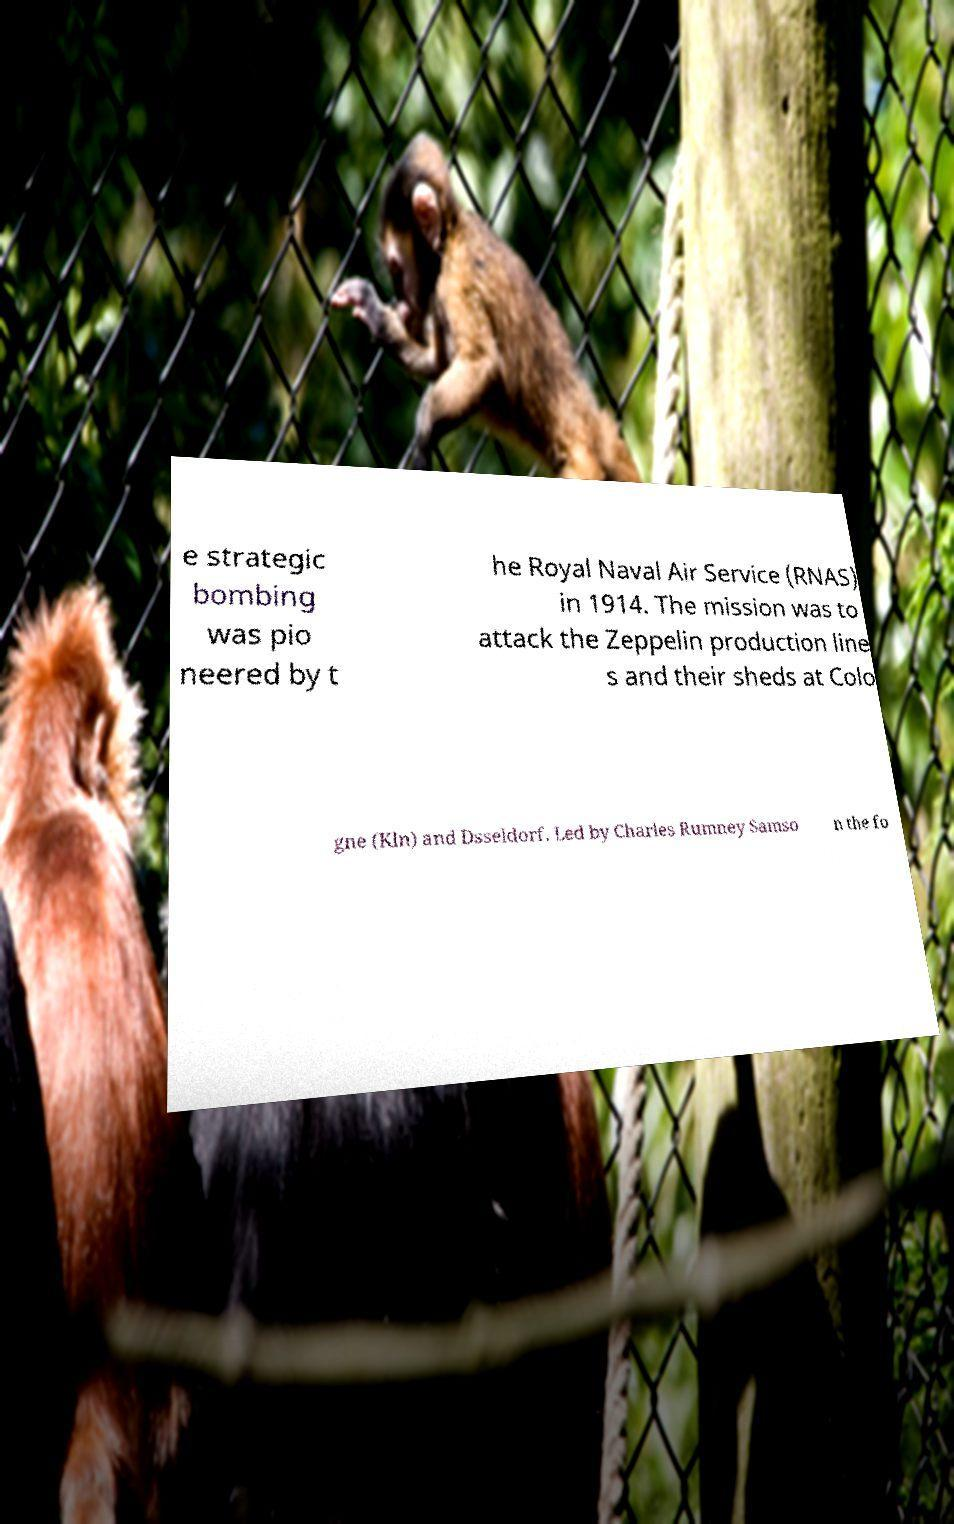Can you accurately transcribe the text from the provided image for me? e strategic bombing was pio neered by t he Royal Naval Air Service (RNAS) in 1914. The mission was to attack the Zeppelin production line s and their sheds at Colo gne (Kln) and Dsseldorf. Led by Charles Rumney Samso n the fo 